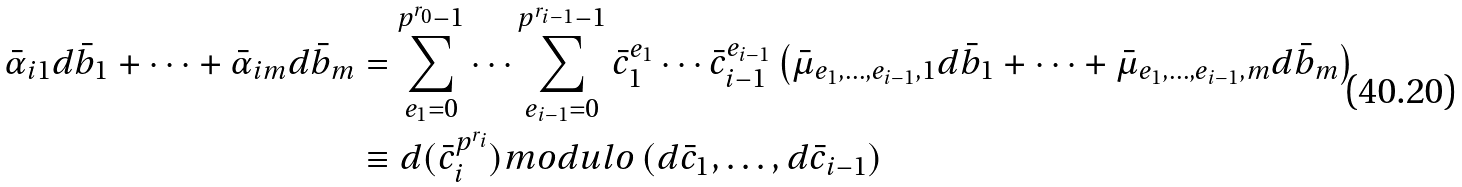Convert formula to latex. <formula><loc_0><loc_0><loc_500><loc_500>\bar { \alpha } _ { i 1 } d \bar { b } _ { 1 } + \cdots + \bar { \alpha } _ { i m } d \bar { b } _ { m } & = \sum _ { e _ { 1 } = 0 } ^ { p ^ { r _ { 0 } } - 1 } \cdots \sum _ { e _ { i - 1 } = 0 } ^ { p ^ { r _ { i - 1 } } - 1 } \bar { c } _ { 1 } ^ { e _ { 1 } } \cdots \bar { c } _ { i - 1 } ^ { e _ { i - 1 } } \left ( \bar { \mu } _ { e _ { 1 } , \dots , e _ { i - 1 } , 1 } d \bar { b } _ { 1 } + \cdots + \bar { \mu } _ { e _ { 1 } , \dots , e _ { i - 1 } , m } d \bar { b } _ { m } \right ) \\ & \equiv d ( \bar { c } _ { i } ^ { p ^ { r _ { i } } } ) m o d u l o \left ( d \bar { c } _ { 1 } , \dots , d \bar { c } _ { i - 1 } \right )</formula> 